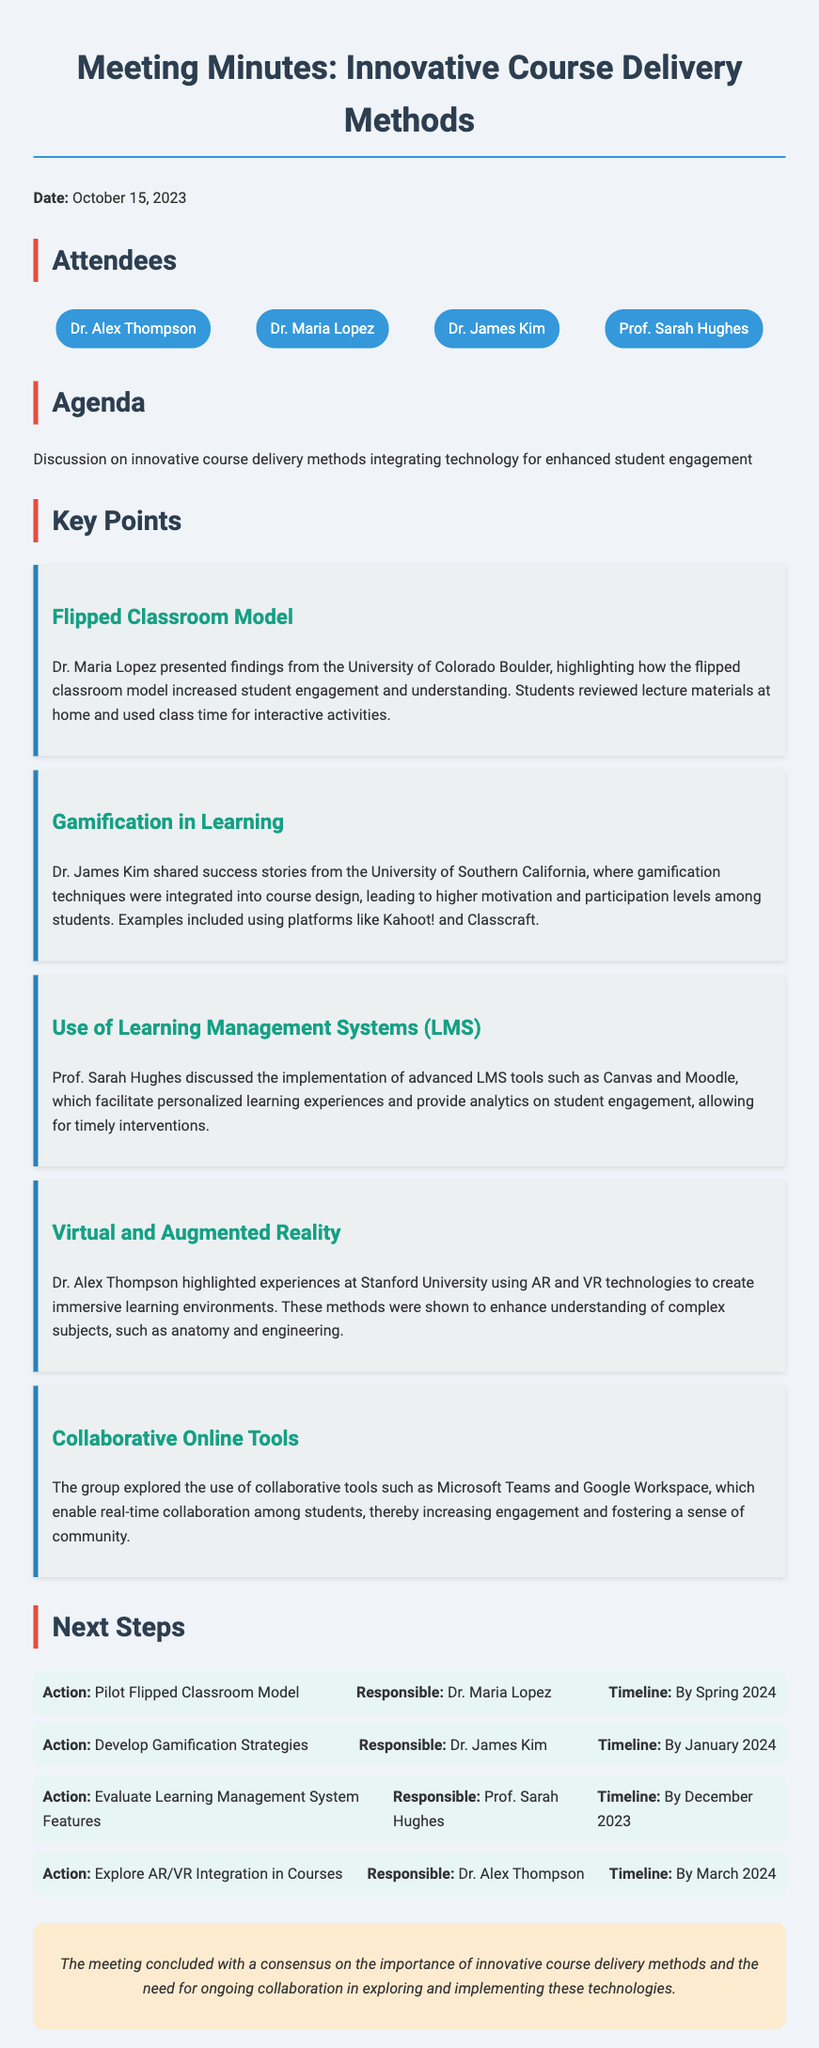What is the date of the meeting? The date of the meeting is stated in the document as October 15, 2023.
Answer: October 15, 2023 Who presented the findings on the Flipped Classroom Model? The document specifies Dr. Maria Lopez presented the findings on the Flipped Classroom Model.
Answer: Dr. Maria Lopez What technology was discussed for creating immersive learning environments? The document indicates that AR and VR technologies were discussed for immersive learning.
Answer: AR and VR What is the timeline for piloting the Flipped Classroom Model? The timeline for piloting the Flipped Classroom Model is mentioned as By Spring 2024.
Answer: By Spring 2024 Which collaborative tools were explored during the meeting? The document lists Microsoft Teams and Google Workspace as the collaborative tools explored.
Answer: Microsoft Teams and Google Workspace Who is responsible for evaluating Learning Management System features? The document states that Prof. Sarah Hughes is responsible for evaluating LMS features.
Answer: Prof. Sarah Hughes How many attendees were present at the meeting? The number of attendees can be counted from the list provided, which shows four names.
Answer: Four What is the primary focus of the meeting? The primary focus of the meeting is described in the agenda section as discussion on innovative course delivery methods.
Answer: Innovative course delivery methods What is the next step for Dr. Alex Thompson? According to the next steps, Dr. Alex Thompson's next step is to explore AR/VR integration in courses.
Answer: Explore AR/VR Integration in Courses 